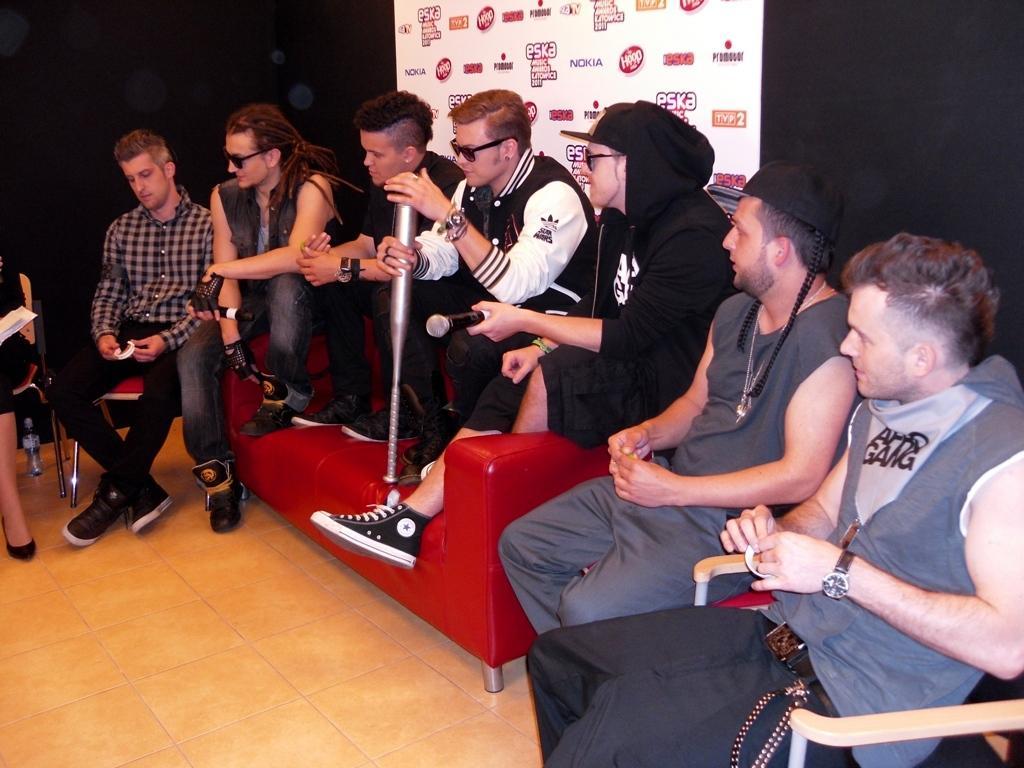In one or two sentences, can you explain what this image depicts? This picture is clicked inside. On the right we can see the two persons wearing t-shirts, holding some objects and sitting on the chairs. In the center we can see the group of persons sitting on the red color couch. On the left there is a person sitting on the chair. In the background we can see a black color curtain and a banner on which we can see the text is printed. 